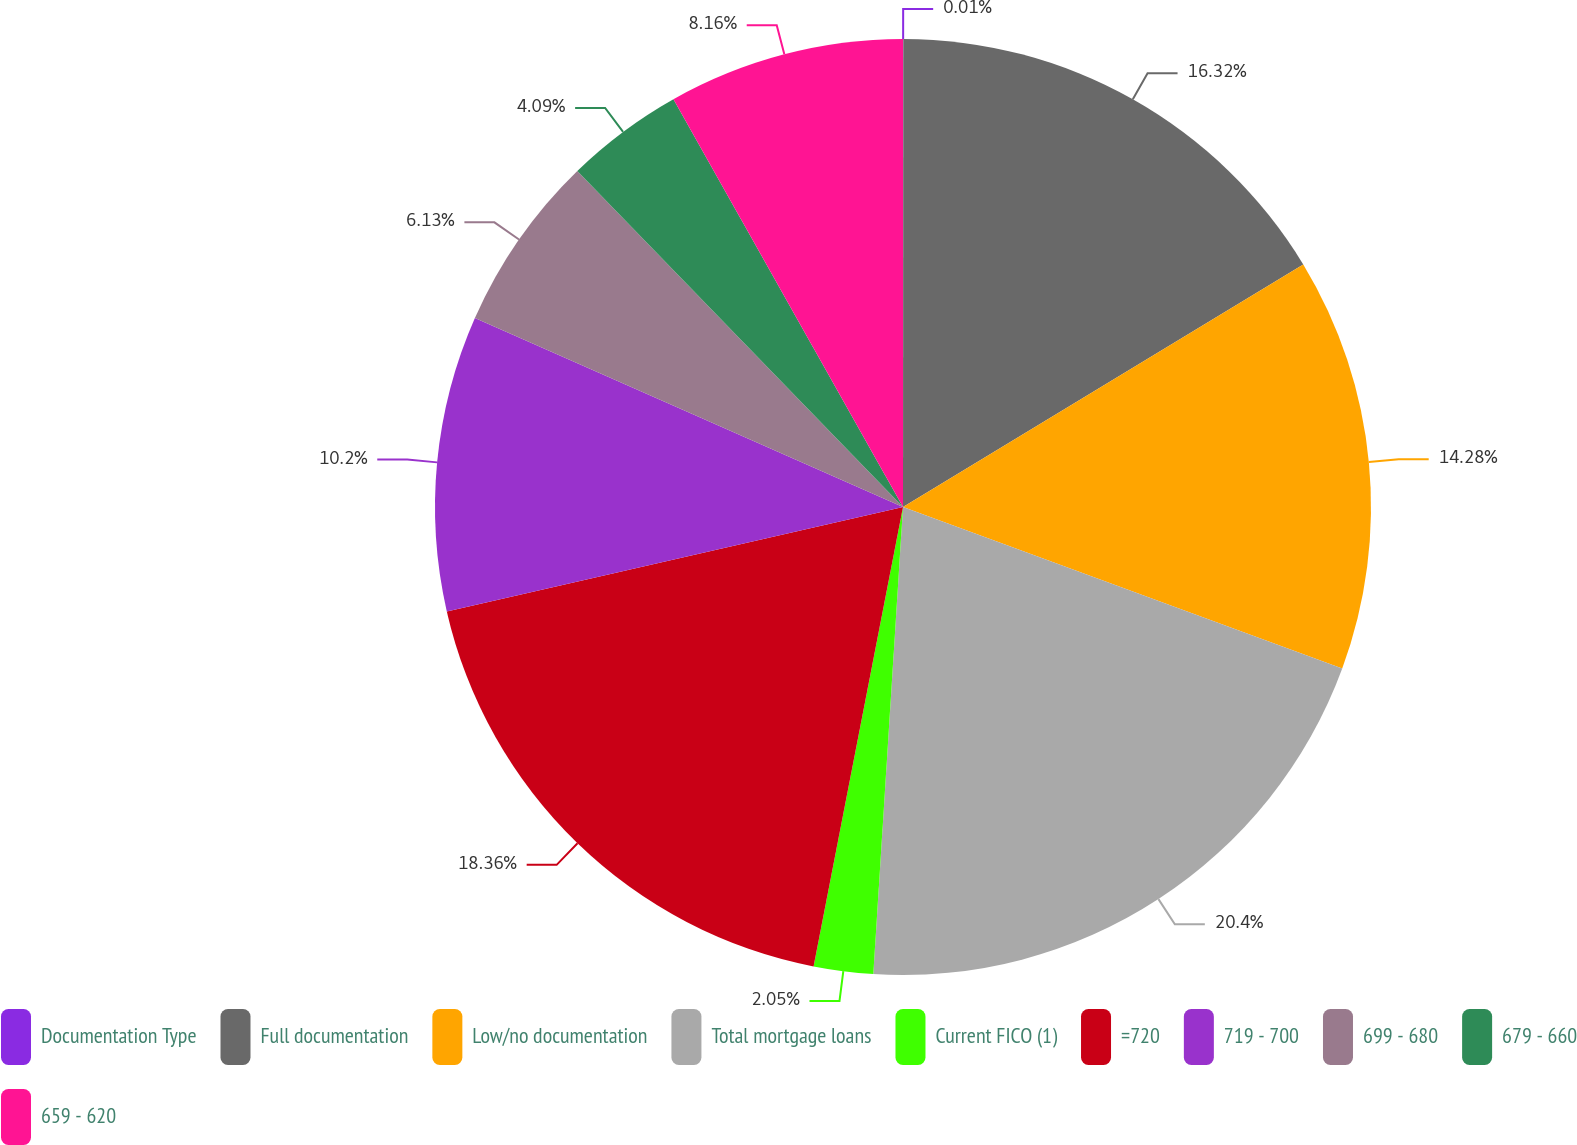<chart> <loc_0><loc_0><loc_500><loc_500><pie_chart><fcel>Documentation Type<fcel>Full documentation<fcel>Low/no documentation<fcel>Total mortgage loans<fcel>Current FICO (1)<fcel>=720<fcel>719 - 700<fcel>699 - 680<fcel>679 - 660<fcel>659 - 620<nl><fcel>0.01%<fcel>16.32%<fcel>14.28%<fcel>20.4%<fcel>2.05%<fcel>18.36%<fcel>10.2%<fcel>6.13%<fcel>4.09%<fcel>8.16%<nl></chart> 